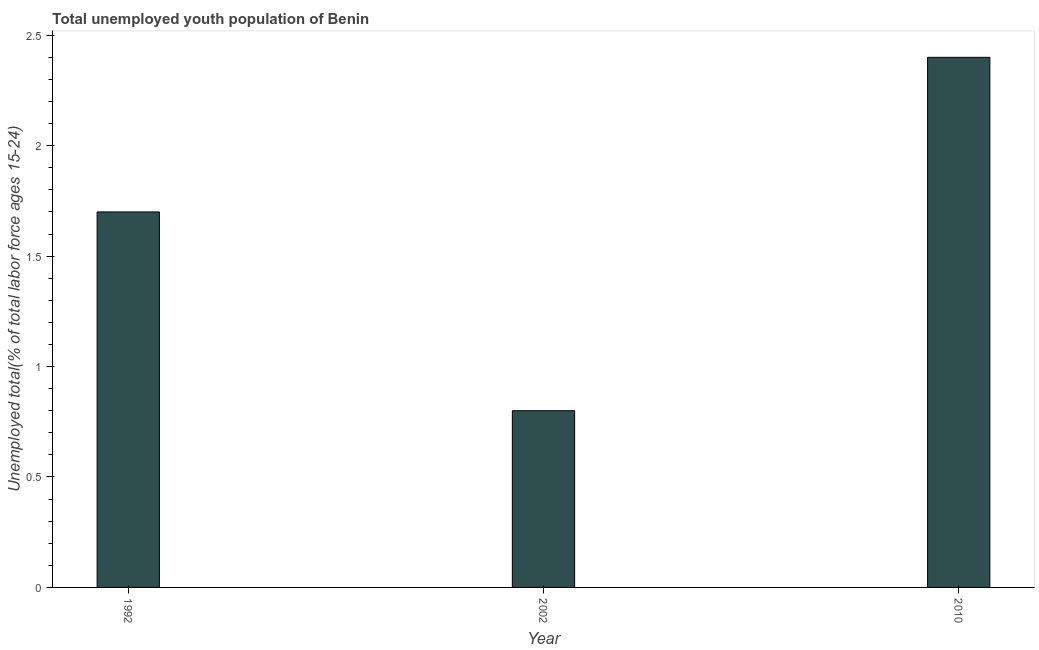Does the graph contain any zero values?
Offer a terse response. No. Does the graph contain grids?
Ensure brevity in your answer.  No. What is the title of the graph?
Offer a very short reply. Total unemployed youth population of Benin. What is the label or title of the X-axis?
Your answer should be very brief. Year. What is the label or title of the Y-axis?
Offer a terse response. Unemployed total(% of total labor force ages 15-24). What is the unemployed youth in 1992?
Offer a very short reply. 1.7. Across all years, what is the maximum unemployed youth?
Your answer should be very brief. 2.4. Across all years, what is the minimum unemployed youth?
Offer a very short reply. 0.8. In which year was the unemployed youth maximum?
Offer a very short reply. 2010. In which year was the unemployed youth minimum?
Offer a terse response. 2002. What is the sum of the unemployed youth?
Offer a terse response. 4.9. What is the average unemployed youth per year?
Ensure brevity in your answer.  1.63. What is the median unemployed youth?
Keep it short and to the point. 1.7. Do a majority of the years between 2002 and 1992 (inclusive) have unemployed youth greater than 1.5 %?
Offer a very short reply. No. What is the ratio of the unemployed youth in 1992 to that in 2010?
Provide a succinct answer. 0.71. Is the unemployed youth in 1992 less than that in 2010?
Keep it short and to the point. Yes. Is the difference between the unemployed youth in 1992 and 2002 greater than the difference between any two years?
Make the answer very short. No. What is the difference between the highest and the lowest unemployed youth?
Your response must be concise. 1.6. In how many years, is the unemployed youth greater than the average unemployed youth taken over all years?
Provide a succinct answer. 2. How many bars are there?
Offer a very short reply. 3. How many years are there in the graph?
Ensure brevity in your answer.  3. What is the Unemployed total(% of total labor force ages 15-24) in 1992?
Keep it short and to the point. 1.7. What is the Unemployed total(% of total labor force ages 15-24) of 2002?
Ensure brevity in your answer.  0.8. What is the Unemployed total(% of total labor force ages 15-24) in 2010?
Ensure brevity in your answer.  2.4. What is the difference between the Unemployed total(% of total labor force ages 15-24) in 1992 and 2002?
Offer a terse response. 0.9. What is the difference between the Unemployed total(% of total labor force ages 15-24) in 1992 and 2010?
Give a very brief answer. -0.7. What is the ratio of the Unemployed total(% of total labor force ages 15-24) in 1992 to that in 2002?
Keep it short and to the point. 2.12. What is the ratio of the Unemployed total(% of total labor force ages 15-24) in 1992 to that in 2010?
Make the answer very short. 0.71. What is the ratio of the Unemployed total(% of total labor force ages 15-24) in 2002 to that in 2010?
Offer a very short reply. 0.33. 